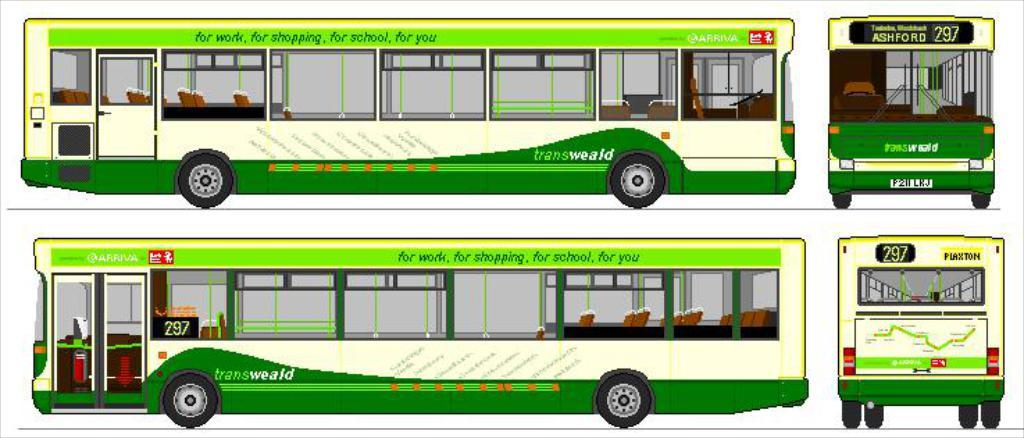What color are the buses in the image? The buses in the image are green-colored. What type of science experiment is being conducted by the sister in the image? There is no sister or science experiment present in the image; it only features green-colored buses. 